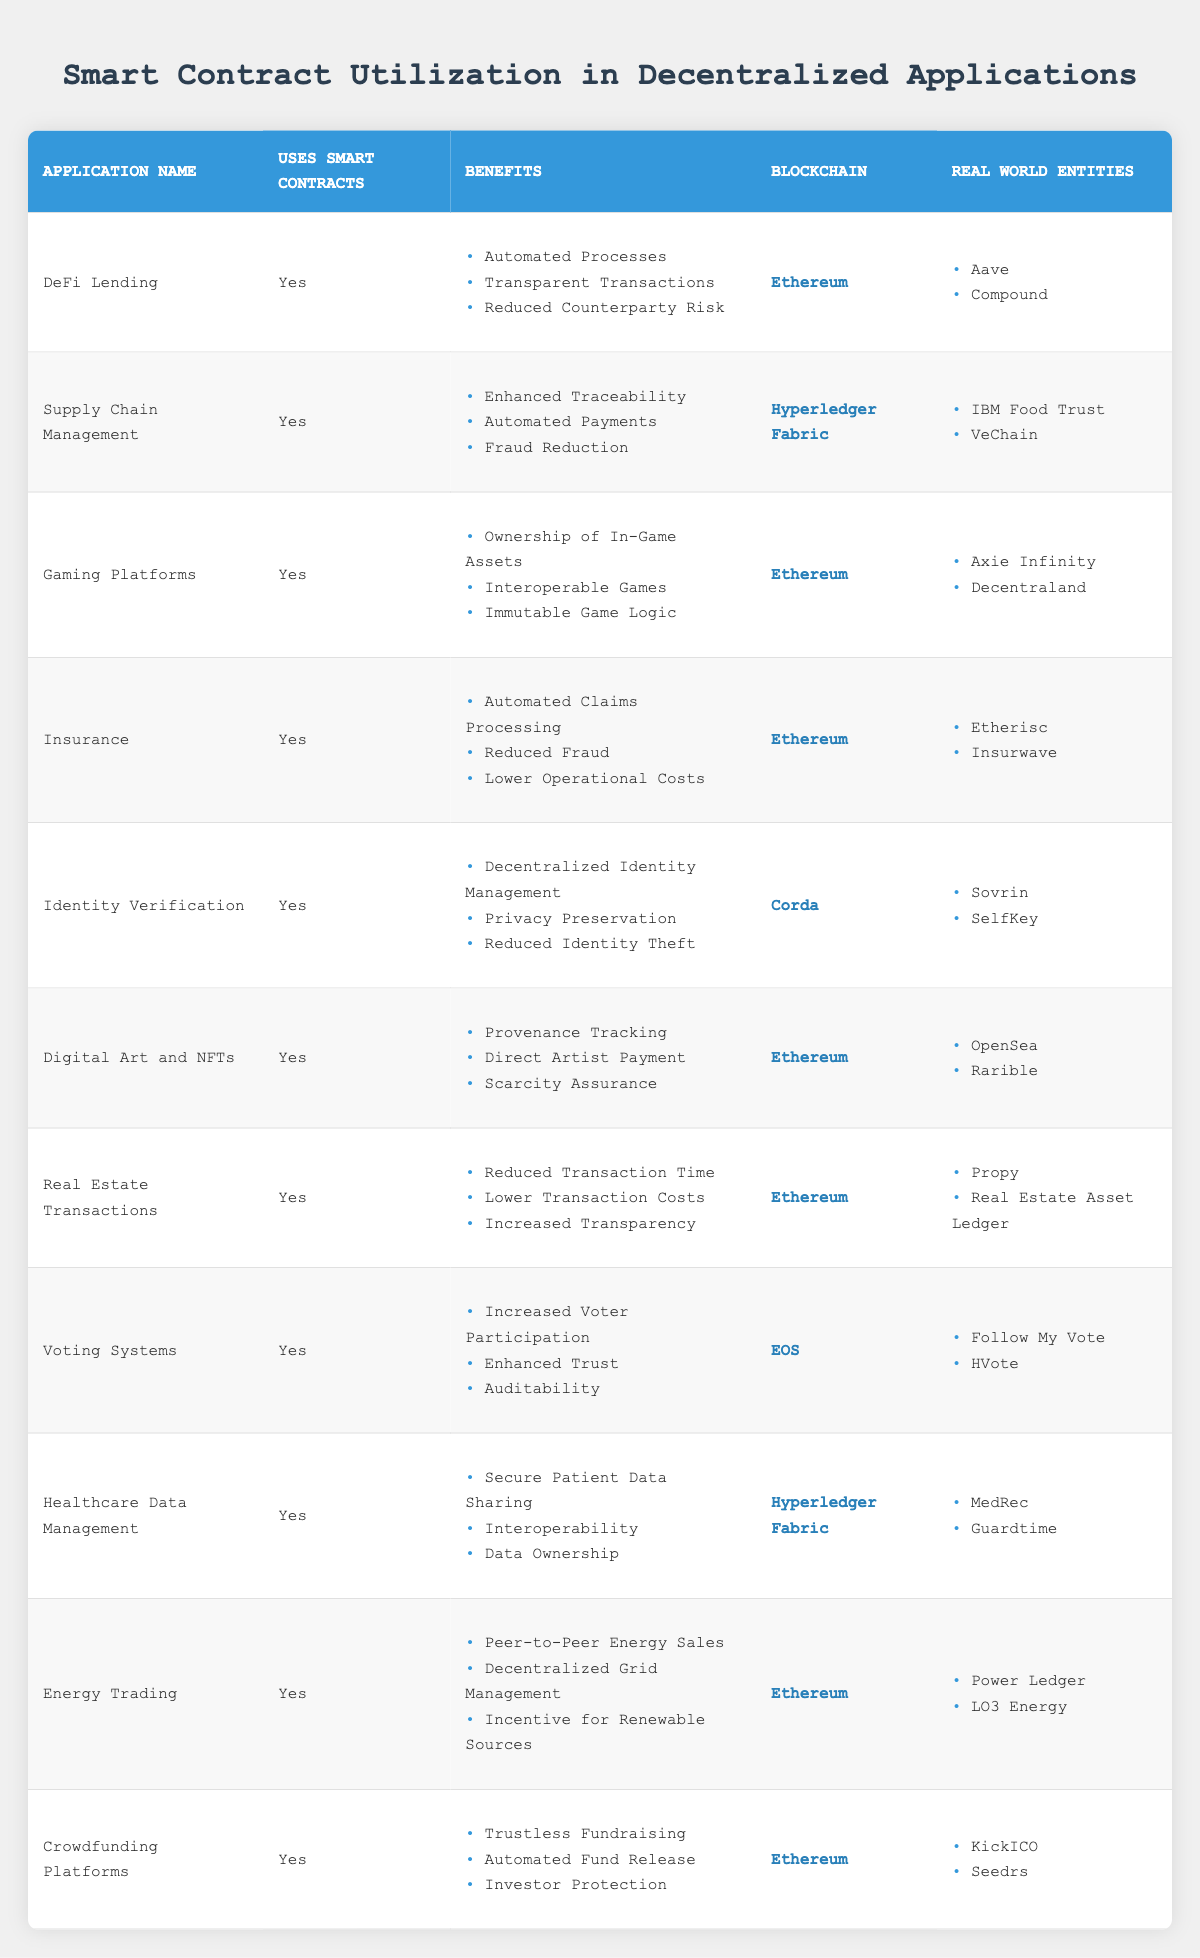What blockchain is used for DeFi Lending? To find the answer, look for the row corresponding to "DeFi Lending" in the table. In that row, the blockchain listed is "Ethereum".
Answer: Ethereum How many applications use Hyperledger Fabric? Check the "uses_smart_contracts" column for applications that utilize smart contracts and have "Hyperledger Fabric" listed in the "blockchain" column. There are 2 applications: "Supply Chain Management" and "Healthcare Data Management".
Answer: 2 Do all applications listed utilize smart contracts? All rows in the table under the "Uses Smart Contracts" column have "Yes" as their value, indicating that every application listed does use smart contracts.
Answer: Yes Which application provides benefits like "Provenance Tracking" and "Direct Artist Payment"? Look for the row which lists these benefits. The application "Digital Art and NFTs" includes both of these benefits in its "Benefits" section.
Answer: Digital Art and NFTs What are the total number of real-world entities listed under Ethereum applications? There are several applications using Ethereum. Count the entities for the applications under this blockchain: "DeFi Lending" has 2, "Gaming Platforms" has 2, "Insurance" has 2, "Digital Art and NFTs" has 2, "Real Estate Transactions" has 2, "Energy Trading" has 2, and "Crowdfunding Platforms" has 2. Summing them up gives 2 + 2 + 2 + 2 + 2 + 2 + 2 = 14.
Answer: 14 Which application has "Increased Voter Participation" as a benefit? Look for the benefit "Increased Voter Participation” in the "Benefits" column. It is associated with the application "Voting Systems".
Answer: Voting Systems Which applications are associated with the real-world entity "Aave"? Cross-reference the "Real World Entities" column to see which application it belongs to. "Aave" is listed under the application "DeFi Lending".
Answer: DeFi Lending How many distinct benefits are listed for the "Insurance" application? Review the "Benefits" section for the "Insurance" application. It lists 3 distinct benefits: "Automated Claims Processing," "Reduced Fraud," and "Lower Operational Costs." Count them: 1, 2, 3.
Answer: 3 Which blockchain has the highest number of applications listed in the table? Check the "blockchain" column for all applications and count how many applications correspond to each blockchain. Ethereum has 7 applications, Hyperledger Fabric has 2, Corda has 1, and EOS has 1. Therefore, the blockchain with the highest number is Ethereum.
Answer: Ethereum 